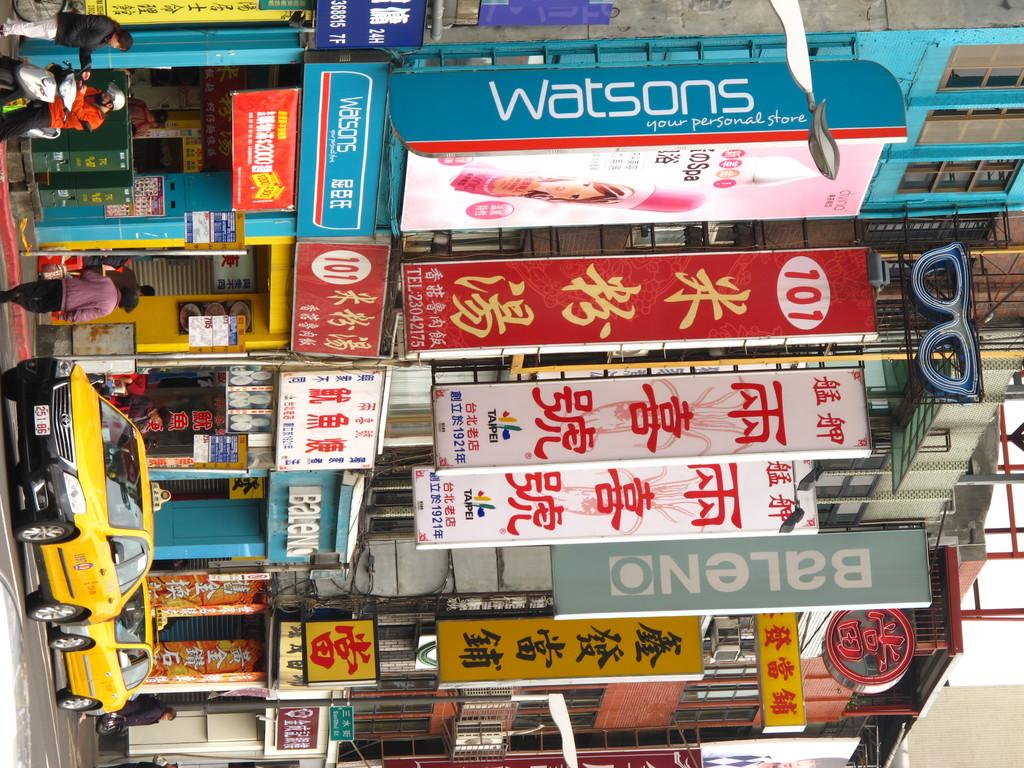<image>
Present a compact description of the photo's key features. A street shot with many banners hanging including Watsons. 